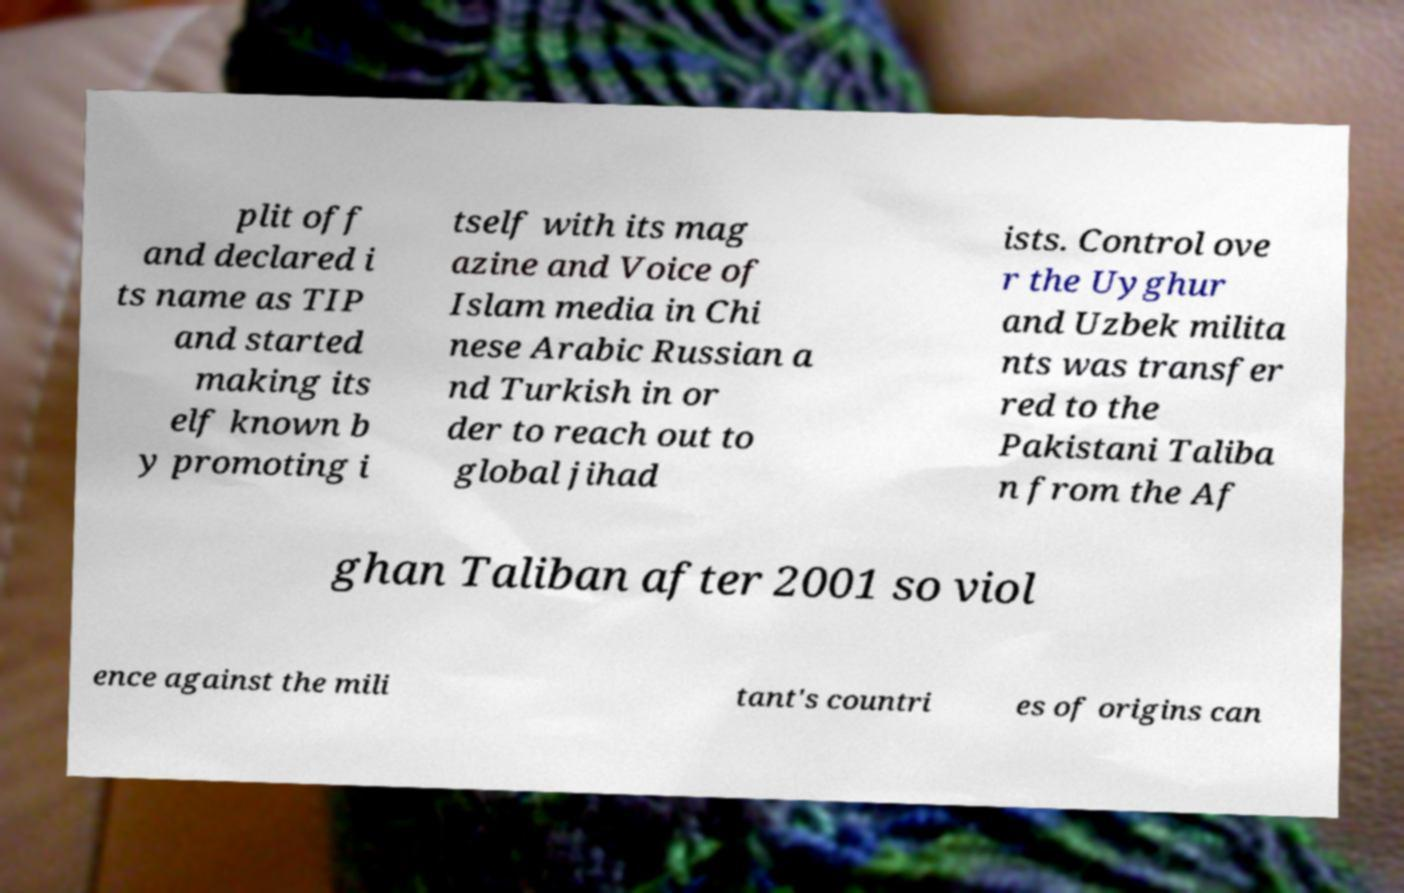What messages or text are displayed in this image? I need them in a readable, typed format. plit off and declared i ts name as TIP and started making its elf known b y promoting i tself with its mag azine and Voice of Islam media in Chi nese Arabic Russian a nd Turkish in or der to reach out to global jihad ists. Control ove r the Uyghur and Uzbek milita nts was transfer red to the Pakistani Taliba n from the Af ghan Taliban after 2001 so viol ence against the mili tant's countri es of origins can 